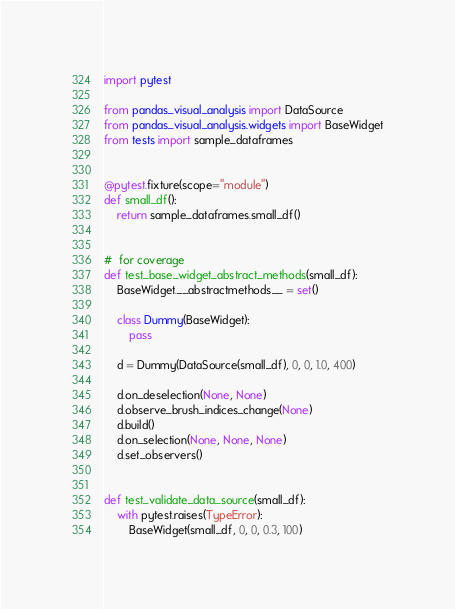Convert code to text. <code><loc_0><loc_0><loc_500><loc_500><_Python_>import pytest

from pandas_visual_analysis import DataSource
from pandas_visual_analysis.widgets import BaseWidget
from tests import sample_dataframes


@pytest.fixture(scope="module")
def small_df():
    return sample_dataframes.small_df()


#  for coverage
def test_base_widget_abstract_methods(small_df):
    BaseWidget.__abstractmethods__ = set()

    class Dummy(BaseWidget):
        pass

    d = Dummy(DataSource(small_df), 0, 0, 1.0, 400)

    d.on_deselection(None, None)
    d.observe_brush_indices_change(None)
    d.build()
    d.on_selection(None, None, None)
    d.set_observers()


def test_validate_data_source(small_df):
    with pytest.raises(TypeError):
        BaseWidget(small_df, 0, 0, 0.3, 100)
</code> 